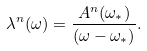<formula> <loc_0><loc_0><loc_500><loc_500>\lambda ^ { n } ( \omega ) = \frac { A ^ { n } ( \omega _ { \ast } ) } { ( \omega - \omega _ { \ast } ) } .</formula> 